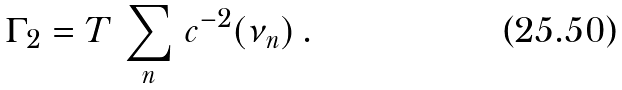<formula> <loc_0><loc_0><loc_500><loc_500>\Gamma _ { 2 } = T \, \sum _ { n } \, c ^ { - 2 } ( \nu _ { n } ) \, .</formula> 